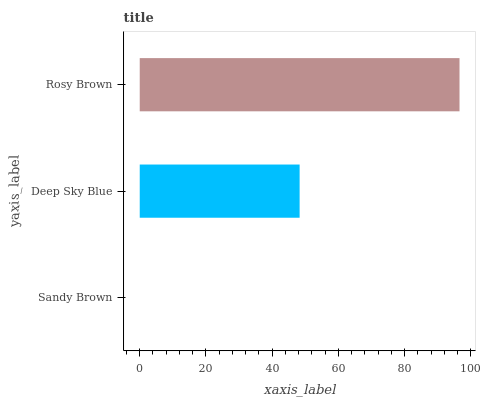Is Sandy Brown the minimum?
Answer yes or no. Yes. Is Rosy Brown the maximum?
Answer yes or no. Yes. Is Deep Sky Blue the minimum?
Answer yes or no. No. Is Deep Sky Blue the maximum?
Answer yes or no. No. Is Deep Sky Blue greater than Sandy Brown?
Answer yes or no. Yes. Is Sandy Brown less than Deep Sky Blue?
Answer yes or no. Yes. Is Sandy Brown greater than Deep Sky Blue?
Answer yes or no. No. Is Deep Sky Blue less than Sandy Brown?
Answer yes or no. No. Is Deep Sky Blue the high median?
Answer yes or no. Yes. Is Deep Sky Blue the low median?
Answer yes or no. Yes. Is Sandy Brown the high median?
Answer yes or no. No. Is Rosy Brown the low median?
Answer yes or no. No. 